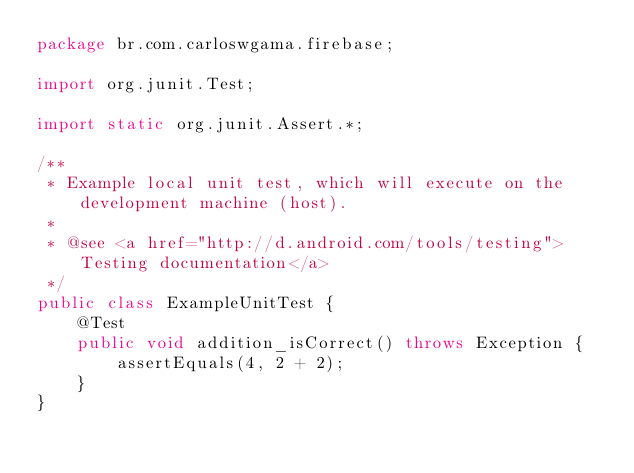<code> <loc_0><loc_0><loc_500><loc_500><_Java_>package br.com.carloswgama.firebase;

import org.junit.Test;

import static org.junit.Assert.*;

/**
 * Example local unit test, which will execute on the development machine (host).
 *
 * @see <a href="http://d.android.com/tools/testing">Testing documentation</a>
 */
public class ExampleUnitTest {
    @Test
    public void addition_isCorrect() throws Exception {
        assertEquals(4, 2 + 2);
    }
}</code> 